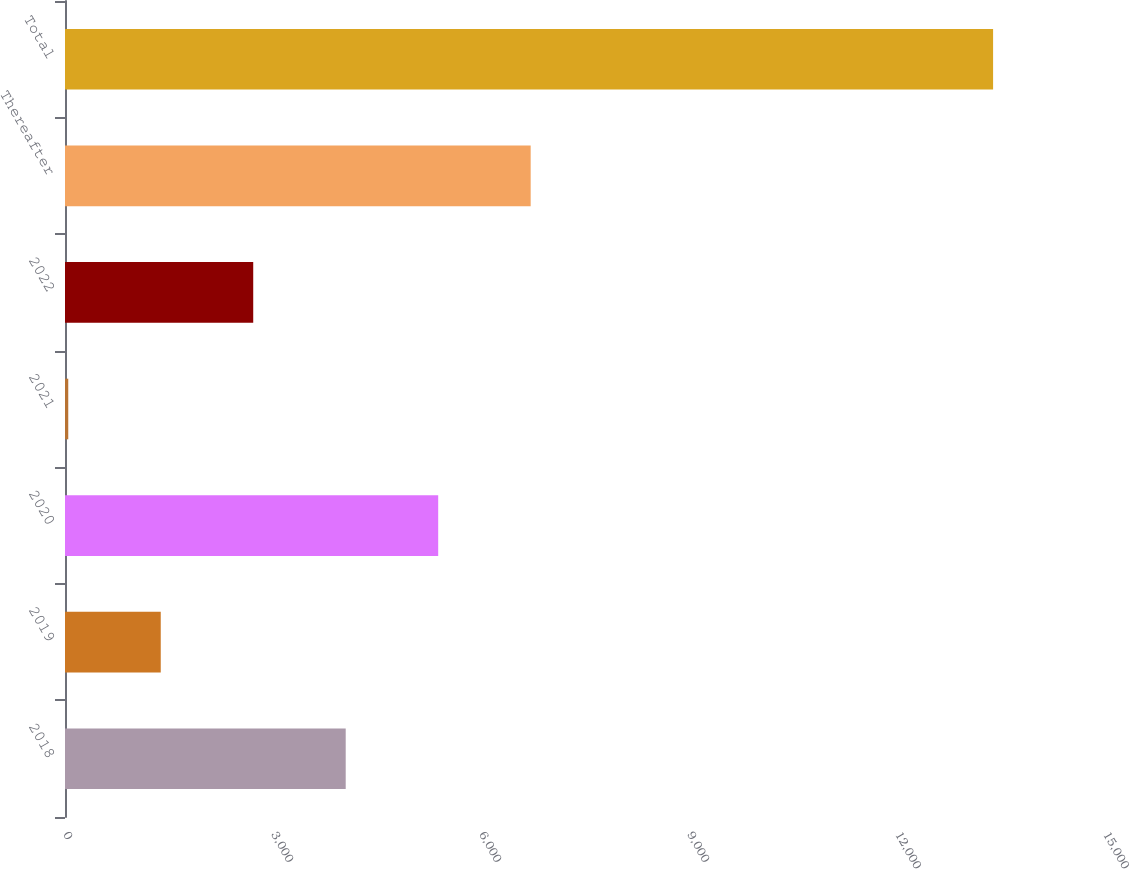Convert chart. <chart><loc_0><loc_0><loc_500><loc_500><bar_chart><fcel>2018<fcel>2019<fcel>2020<fcel>2021<fcel>2022<fcel>Thereafter<fcel>Total<nl><fcel>4048.7<fcel>1380.9<fcel>5382.6<fcel>47<fcel>2714.8<fcel>6716.5<fcel>13386<nl></chart> 